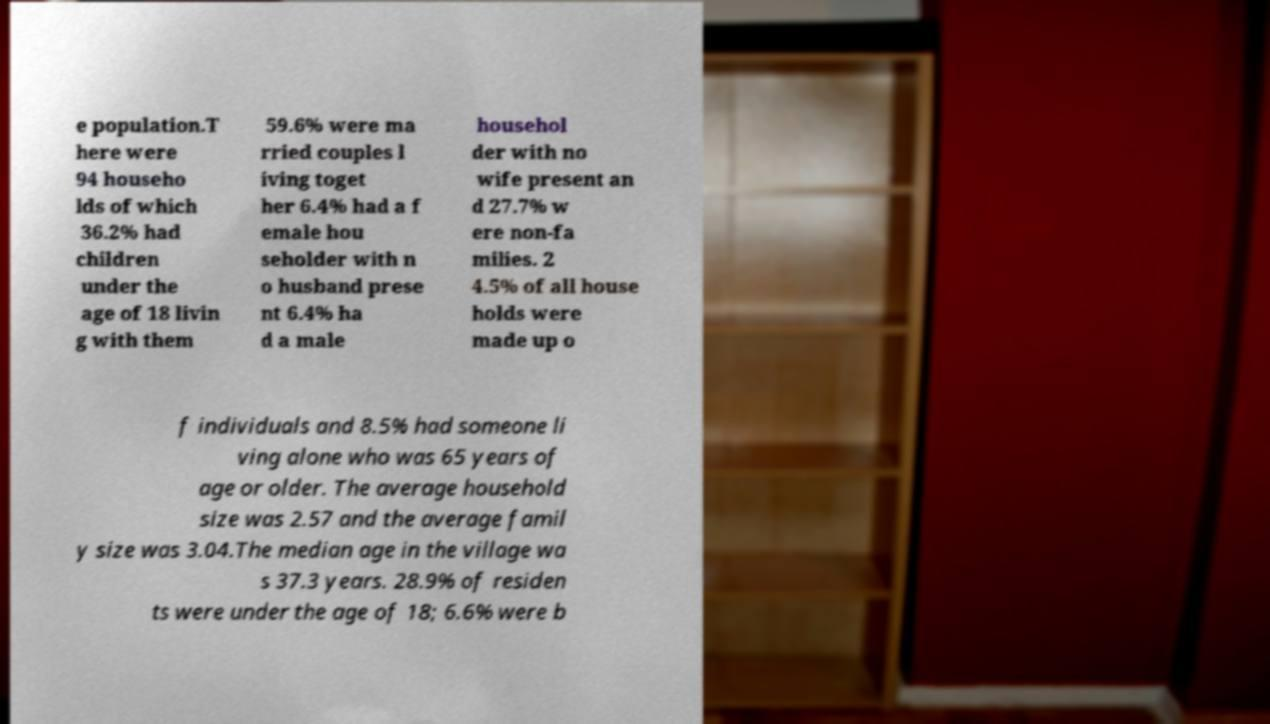Please identify and transcribe the text found in this image. e population.T here were 94 househo lds of which 36.2% had children under the age of 18 livin g with them 59.6% were ma rried couples l iving toget her 6.4% had a f emale hou seholder with n o husband prese nt 6.4% ha d a male househol der with no wife present an d 27.7% w ere non-fa milies. 2 4.5% of all house holds were made up o f individuals and 8.5% had someone li ving alone who was 65 years of age or older. The average household size was 2.57 and the average famil y size was 3.04.The median age in the village wa s 37.3 years. 28.9% of residen ts were under the age of 18; 6.6% were b 